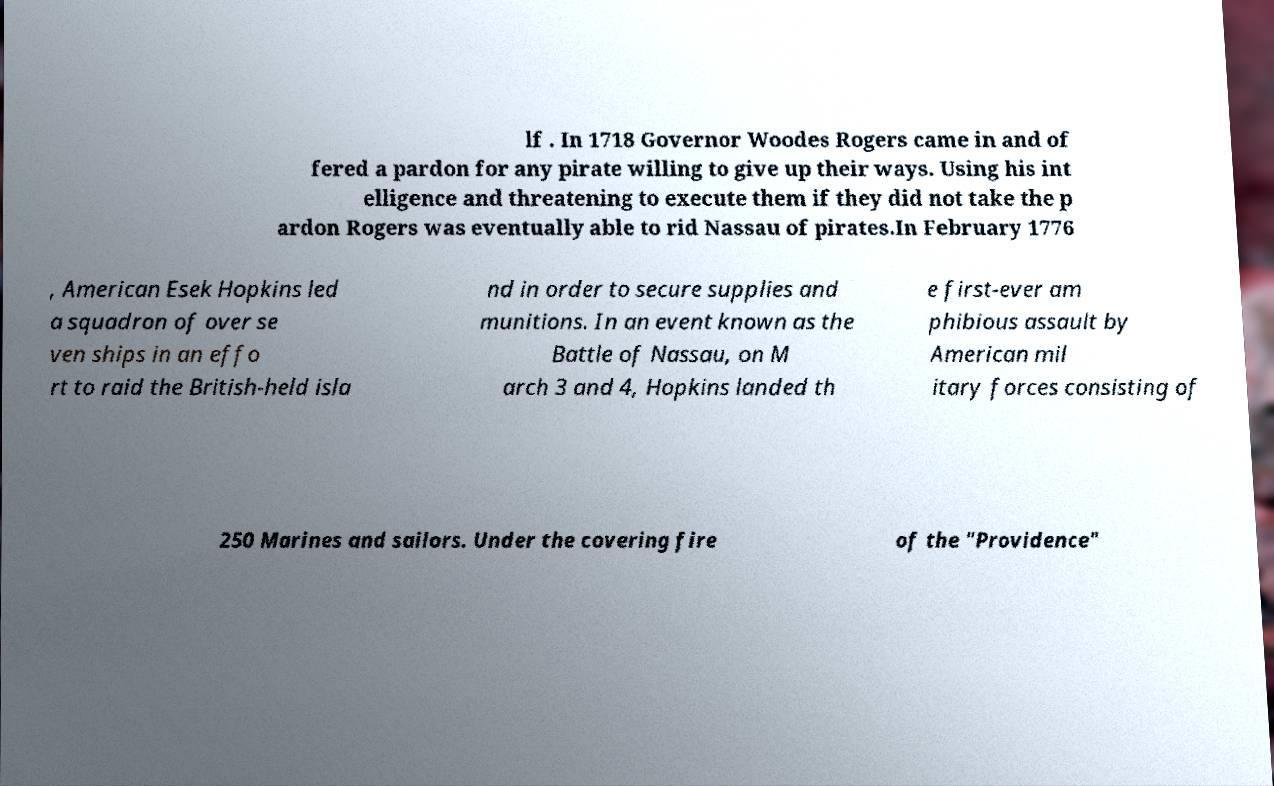Can you read and provide the text displayed in the image?This photo seems to have some interesting text. Can you extract and type it out for me? lf . In 1718 Governor Woodes Rogers came in and of fered a pardon for any pirate willing to give up their ways. Using his int elligence and threatening to execute them if they did not take the p ardon Rogers was eventually able to rid Nassau of pirates.In February 1776 , American Esek Hopkins led a squadron of over se ven ships in an effo rt to raid the British-held isla nd in order to secure supplies and munitions. In an event known as the Battle of Nassau, on M arch 3 and 4, Hopkins landed th e first-ever am phibious assault by American mil itary forces consisting of 250 Marines and sailors. Under the covering fire of the "Providence" 